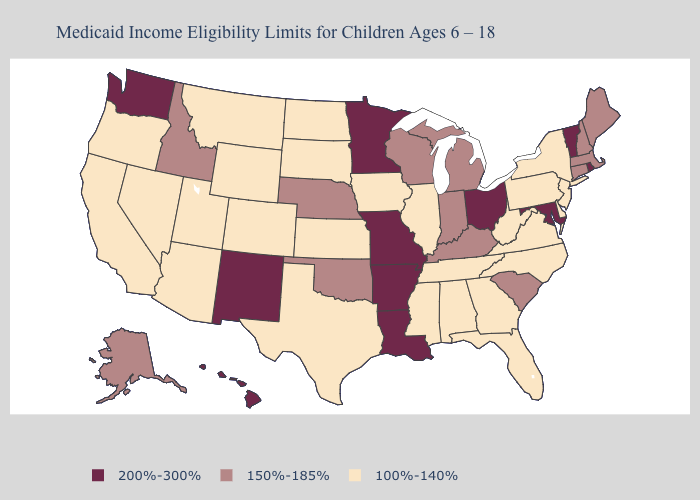Does the map have missing data?
Keep it brief. No. What is the lowest value in the West?
Write a very short answer. 100%-140%. Name the states that have a value in the range 100%-140%?
Give a very brief answer. Alabama, Arizona, California, Colorado, Delaware, Florida, Georgia, Illinois, Iowa, Kansas, Mississippi, Montana, Nevada, New Jersey, New York, North Carolina, North Dakota, Oregon, Pennsylvania, South Dakota, Tennessee, Texas, Utah, Virginia, West Virginia, Wyoming. Does Alabama have the lowest value in the USA?
Concise answer only. Yes. Does Mississippi have the lowest value in the USA?
Short answer required. Yes. Which states hav the highest value in the Northeast?
Keep it brief. Rhode Island, Vermont. Which states have the lowest value in the USA?
Concise answer only. Alabama, Arizona, California, Colorado, Delaware, Florida, Georgia, Illinois, Iowa, Kansas, Mississippi, Montana, Nevada, New Jersey, New York, North Carolina, North Dakota, Oregon, Pennsylvania, South Dakota, Tennessee, Texas, Utah, Virginia, West Virginia, Wyoming. Name the states that have a value in the range 150%-185%?
Concise answer only. Alaska, Connecticut, Idaho, Indiana, Kentucky, Maine, Massachusetts, Michigan, Nebraska, New Hampshire, Oklahoma, South Carolina, Wisconsin. Does Wyoming have a lower value than Idaho?
Answer briefly. Yes. Among the states that border North Dakota , which have the highest value?
Write a very short answer. Minnesota. Is the legend a continuous bar?
Give a very brief answer. No. Name the states that have a value in the range 200%-300%?
Write a very short answer. Arkansas, Hawaii, Louisiana, Maryland, Minnesota, Missouri, New Mexico, Ohio, Rhode Island, Vermont, Washington. Is the legend a continuous bar?
Answer briefly. No. Does Iowa have the same value as Alabama?
Short answer required. Yes. Name the states that have a value in the range 150%-185%?
Give a very brief answer. Alaska, Connecticut, Idaho, Indiana, Kentucky, Maine, Massachusetts, Michigan, Nebraska, New Hampshire, Oklahoma, South Carolina, Wisconsin. 